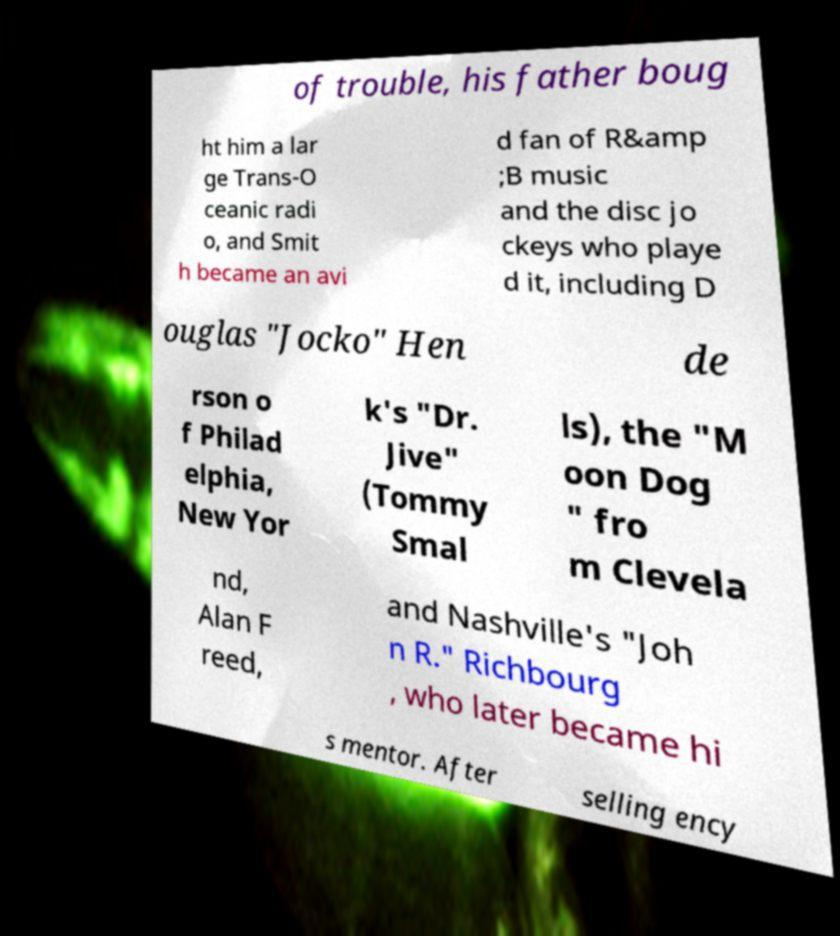I need the written content from this picture converted into text. Can you do that? of trouble, his father boug ht him a lar ge Trans-O ceanic radi o, and Smit h became an avi d fan of R&amp ;B music and the disc jo ckeys who playe d it, including D ouglas "Jocko" Hen de rson o f Philad elphia, New Yor k's "Dr. Jive" (Tommy Smal ls), the "M oon Dog " fro m Clevela nd, Alan F reed, and Nashville's "Joh n R." Richbourg , who later became hi s mentor. After selling ency 